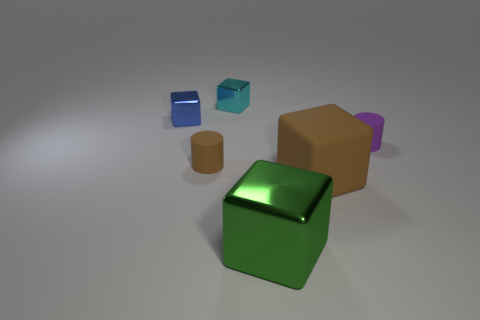Is there anything else that is the same shape as the blue metal object?
Make the answer very short. Yes. The big matte block has what color?
Your answer should be very brief. Brown. What number of other tiny brown rubber objects have the same shape as the small brown object?
Give a very brief answer. 0. What is the color of the other shiny thing that is the same size as the cyan object?
Make the answer very short. Blue. Are any big gray rubber spheres visible?
Provide a succinct answer. No. What shape is the tiny thing that is behind the blue cube?
Give a very brief answer. Cube. How many small things are both to the left of the purple object and in front of the cyan cube?
Give a very brief answer. 2. Are there any large blocks that have the same material as the small cyan object?
Keep it short and to the point. Yes. The matte object that is the same color as the matte cube is what size?
Offer a terse response. Small. How many cylinders are either green metal things or small metal things?
Offer a terse response. 0. 